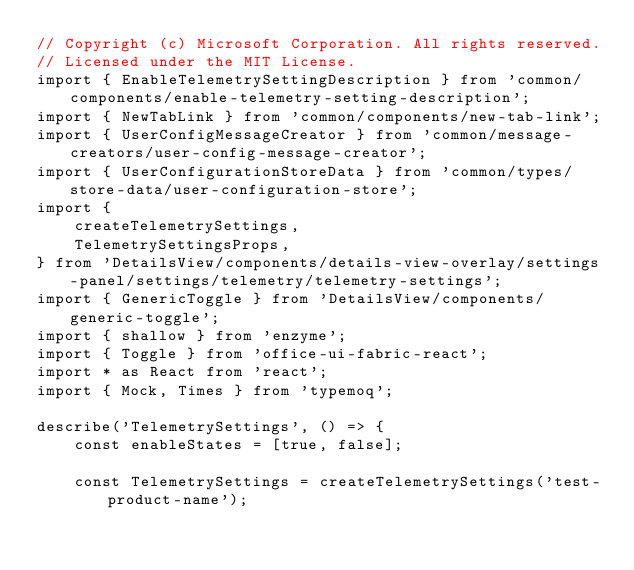Convert code to text. <code><loc_0><loc_0><loc_500><loc_500><_TypeScript_>// Copyright (c) Microsoft Corporation. All rights reserved.
// Licensed under the MIT License.
import { EnableTelemetrySettingDescription } from 'common/components/enable-telemetry-setting-description';
import { NewTabLink } from 'common/components/new-tab-link';
import { UserConfigMessageCreator } from 'common/message-creators/user-config-message-creator';
import { UserConfigurationStoreData } from 'common/types/store-data/user-configuration-store';
import {
    createTelemetrySettings,
    TelemetrySettingsProps,
} from 'DetailsView/components/details-view-overlay/settings-panel/settings/telemetry/telemetry-settings';
import { GenericToggle } from 'DetailsView/components/generic-toggle';
import { shallow } from 'enzyme';
import { Toggle } from 'office-ui-fabric-react';
import * as React from 'react';
import { Mock, Times } from 'typemoq';

describe('TelemetrySettings', () => {
    const enableStates = [true, false];

    const TelemetrySettings = createTelemetrySettings('test-product-name');
</code> 